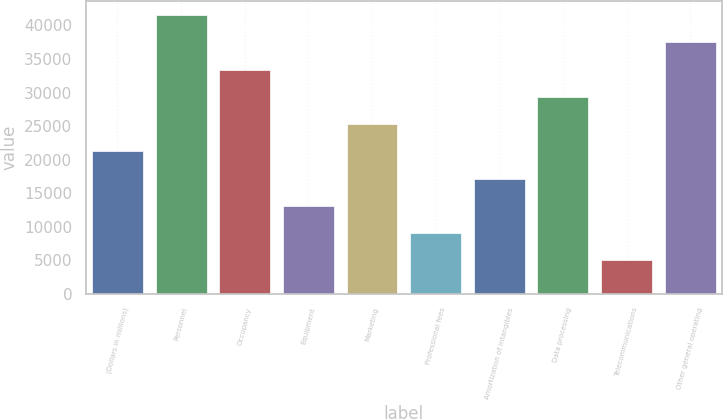Convert chart. <chart><loc_0><loc_0><loc_500><loc_500><bar_chart><fcel>(Dollars in millions)<fcel>Personnel<fcel>Occupancy<fcel>Equipment<fcel>Marketing<fcel>Professional fees<fcel>Amortization of intangibles<fcel>Data processing<fcel>Telecommunications<fcel>Other general operating<nl><fcel>21232<fcel>41529<fcel>33410.2<fcel>13113.2<fcel>25291.4<fcel>9053.8<fcel>17172.6<fcel>29350.8<fcel>4994.4<fcel>37469.6<nl></chart> 